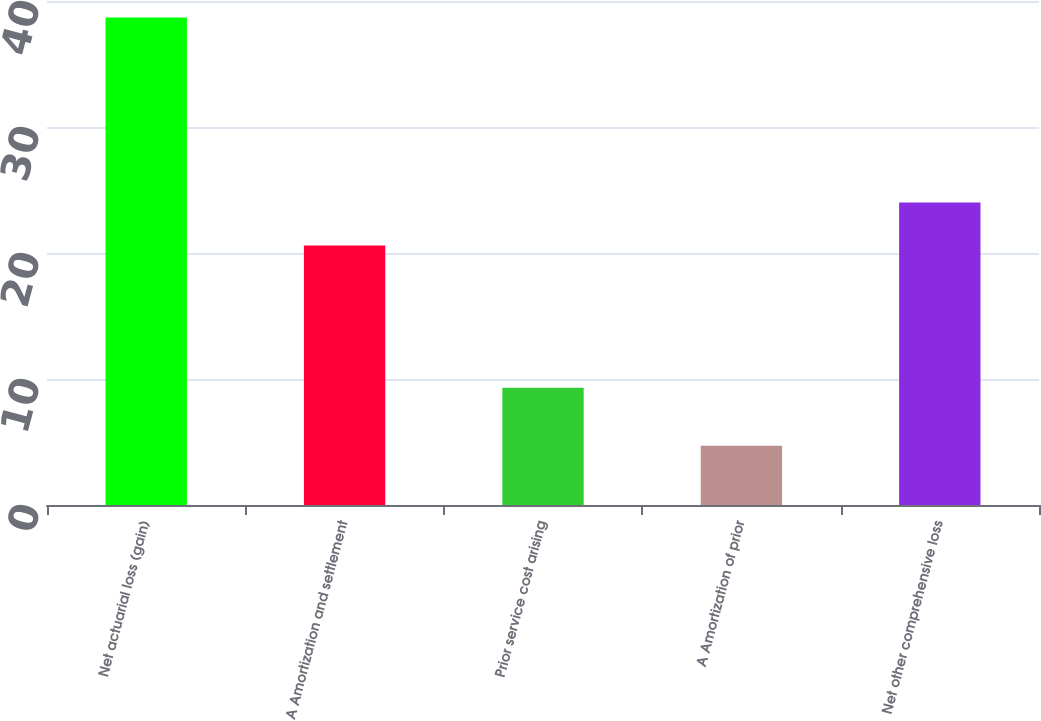<chart> <loc_0><loc_0><loc_500><loc_500><bar_chart><fcel>Net actuarial loss (gain)<fcel>A Amortization and settlement<fcel>Prior service cost arising<fcel>A Amortization of prior<fcel>Net other comprehensive loss<nl><fcel>38.7<fcel>20.6<fcel>9.3<fcel>4.7<fcel>24<nl></chart> 